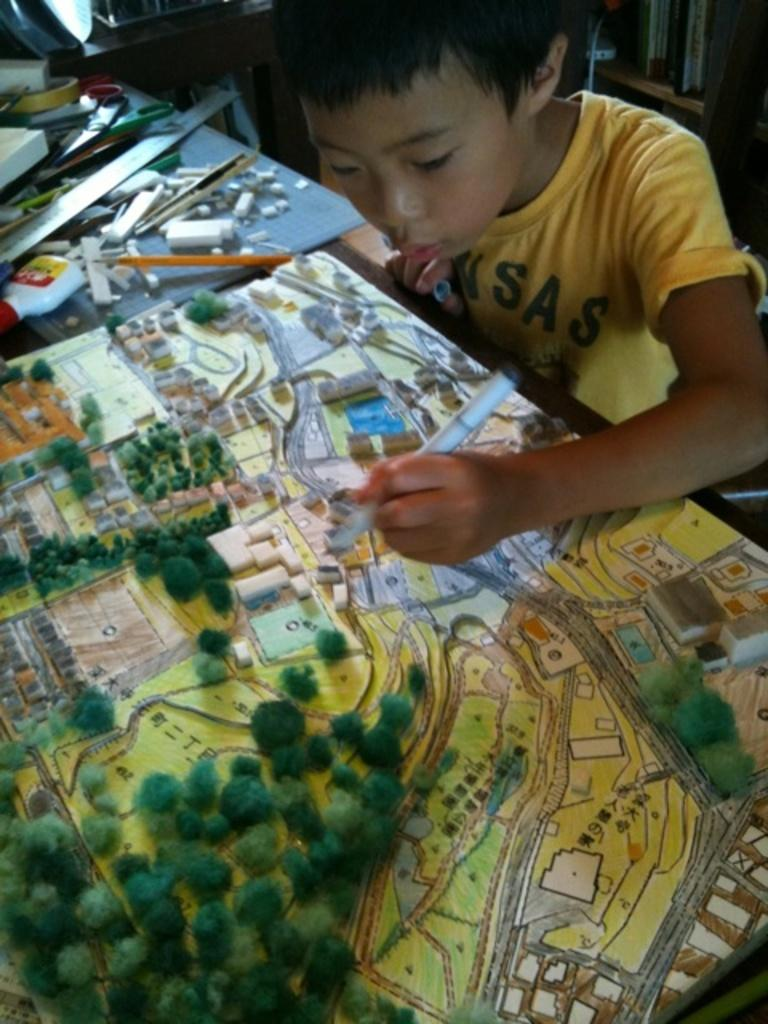Who is the main subject in the image? There is a child in the image. What is the child doing in the image? The child is sitting on a chair. What is in front of the child? There is a table in front of the child. What items can be seen on the table? Stationery, scissors, and a building model of a map are present on the table. What type of duck can be seen swimming in the box on the table? There is no duck or box present on the table in the image. What type of prose is the child reading from the building model of a map? The image does not show the child reading any prose, and the building model of a map is not a source of prose. 